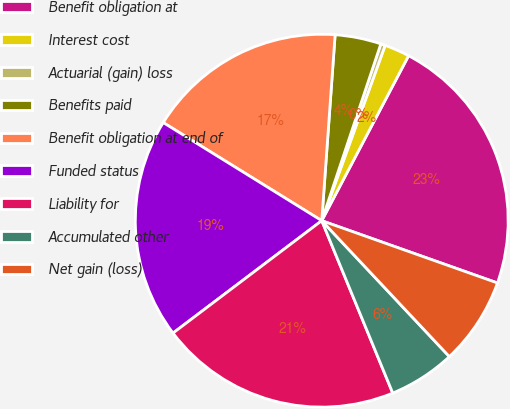Convert chart to OTSL. <chart><loc_0><loc_0><loc_500><loc_500><pie_chart><fcel>Benefit obligation at<fcel>Interest cost<fcel>Actuarial (gain) loss<fcel>Benefits paid<fcel>Benefit obligation at end of<fcel>Funded status<fcel>Liability for<fcel>Accumulated other<fcel>Net gain (loss)<nl><fcel>22.71%<fcel>2.19%<fcel>0.39%<fcel>3.99%<fcel>17.32%<fcel>19.12%<fcel>20.92%<fcel>5.78%<fcel>7.58%<nl></chart> 